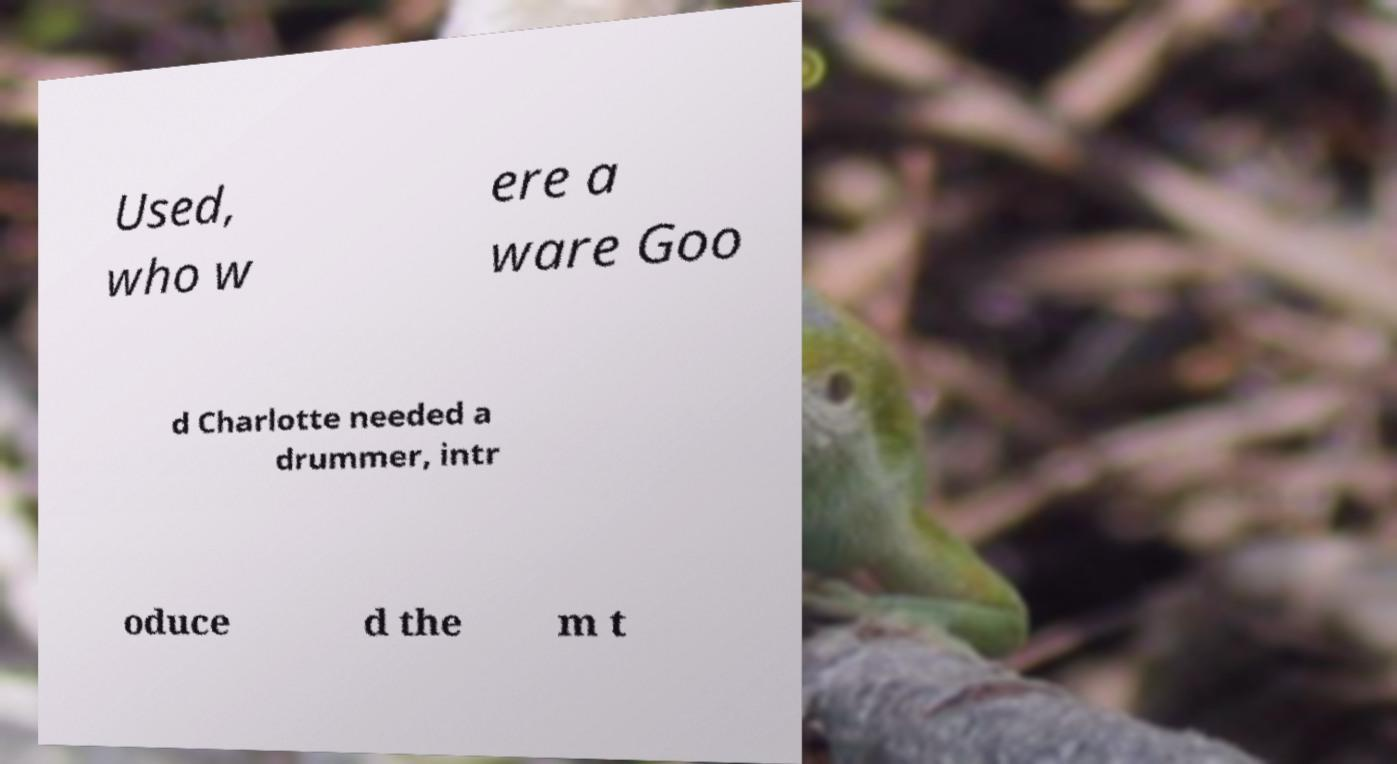For documentation purposes, I need the text within this image transcribed. Could you provide that? Used, who w ere a ware Goo d Charlotte needed a drummer, intr oduce d the m t 